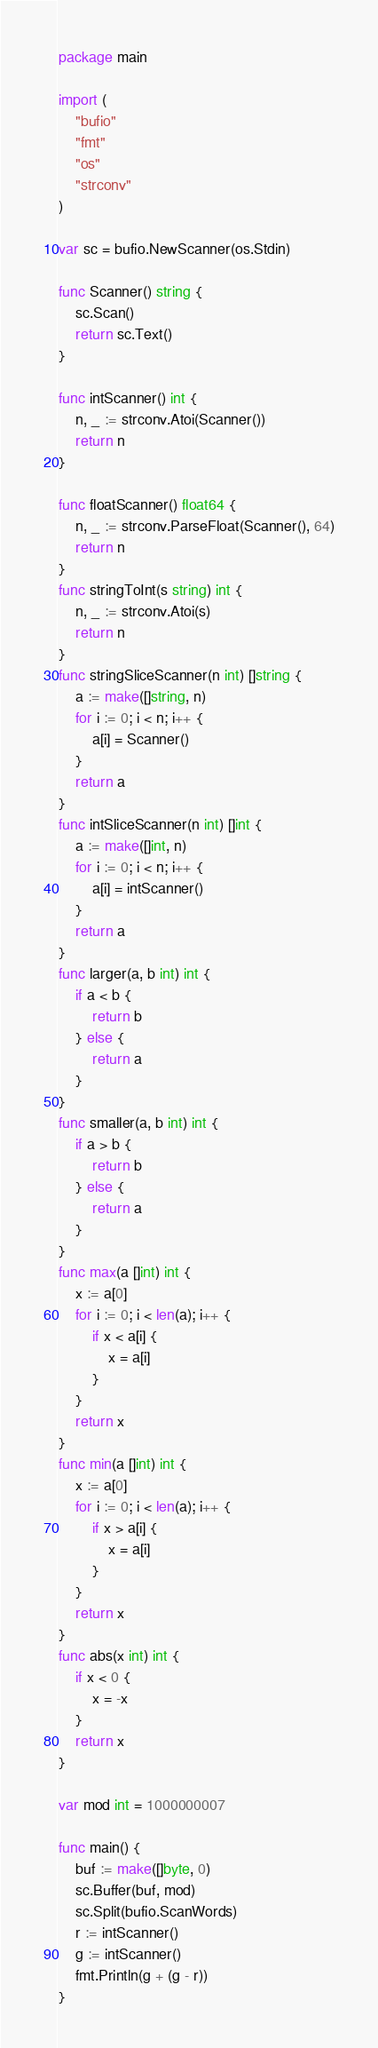<code> <loc_0><loc_0><loc_500><loc_500><_Go_>package main

import (
	"bufio"
	"fmt"
	"os"
	"strconv"
)

var sc = bufio.NewScanner(os.Stdin)

func Scanner() string {
	sc.Scan()
	return sc.Text()
}

func intScanner() int {
	n, _ := strconv.Atoi(Scanner())
	return n
}

func floatScanner() float64 {
	n, _ := strconv.ParseFloat(Scanner(), 64)
	return n
}
func stringToInt(s string) int {
	n, _ := strconv.Atoi(s)
	return n
}
func stringSliceScanner(n int) []string {
	a := make([]string, n)
	for i := 0; i < n; i++ {
		a[i] = Scanner()
	}
	return a
}
func intSliceScanner(n int) []int {
	a := make([]int, n)
	for i := 0; i < n; i++ {
		a[i] = intScanner()
	}
	return a
}
func larger(a, b int) int {
	if a < b {
		return b
	} else {
		return a
	}
}
func smaller(a, b int) int {
	if a > b {
		return b
	} else {
		return a
	}
}
func max(a []int) int {
	x := a[0]
	for i := 0; i < len(a); i++ {
		if x < a[i] {
			x = a[i]
		}
	}
	return x
}
func min(a []int) int {
	x := a[0]
	for i := 0; i < len(a); i++ {
		if x > a[i] {
			x = a[i]
		}
	}
	return x
}
func abs(x int) int {
	if x < 0 {
		x = -x
	}
	return x
}

var mod int = 1000000007

func main() {
	buf := make([]byte, 0)
	sc.Buffer(buf, mod)
	sc.Split(bufio.ScanWords)
	r := intScanner()
	g := intScanner()
	fmt.Println(g + (g - r))
}
</code> 